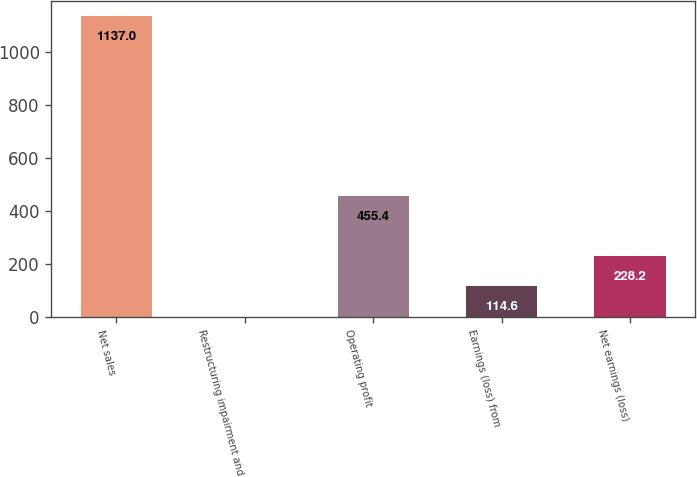Convert chart to OTSL. <chart><loc_0><loc_0><loc_500><loc_500><bar_chart><fcel>Net sales<fcel>Restructuring impairment and<fcel>Operating profit<fcel>Earnings (loss) from<fcel>Net earnings (loss)<nl><fcel>1137<fcel>1<fcel>455.4<fcel>114.6<fcel>228.2<nl></chart> 